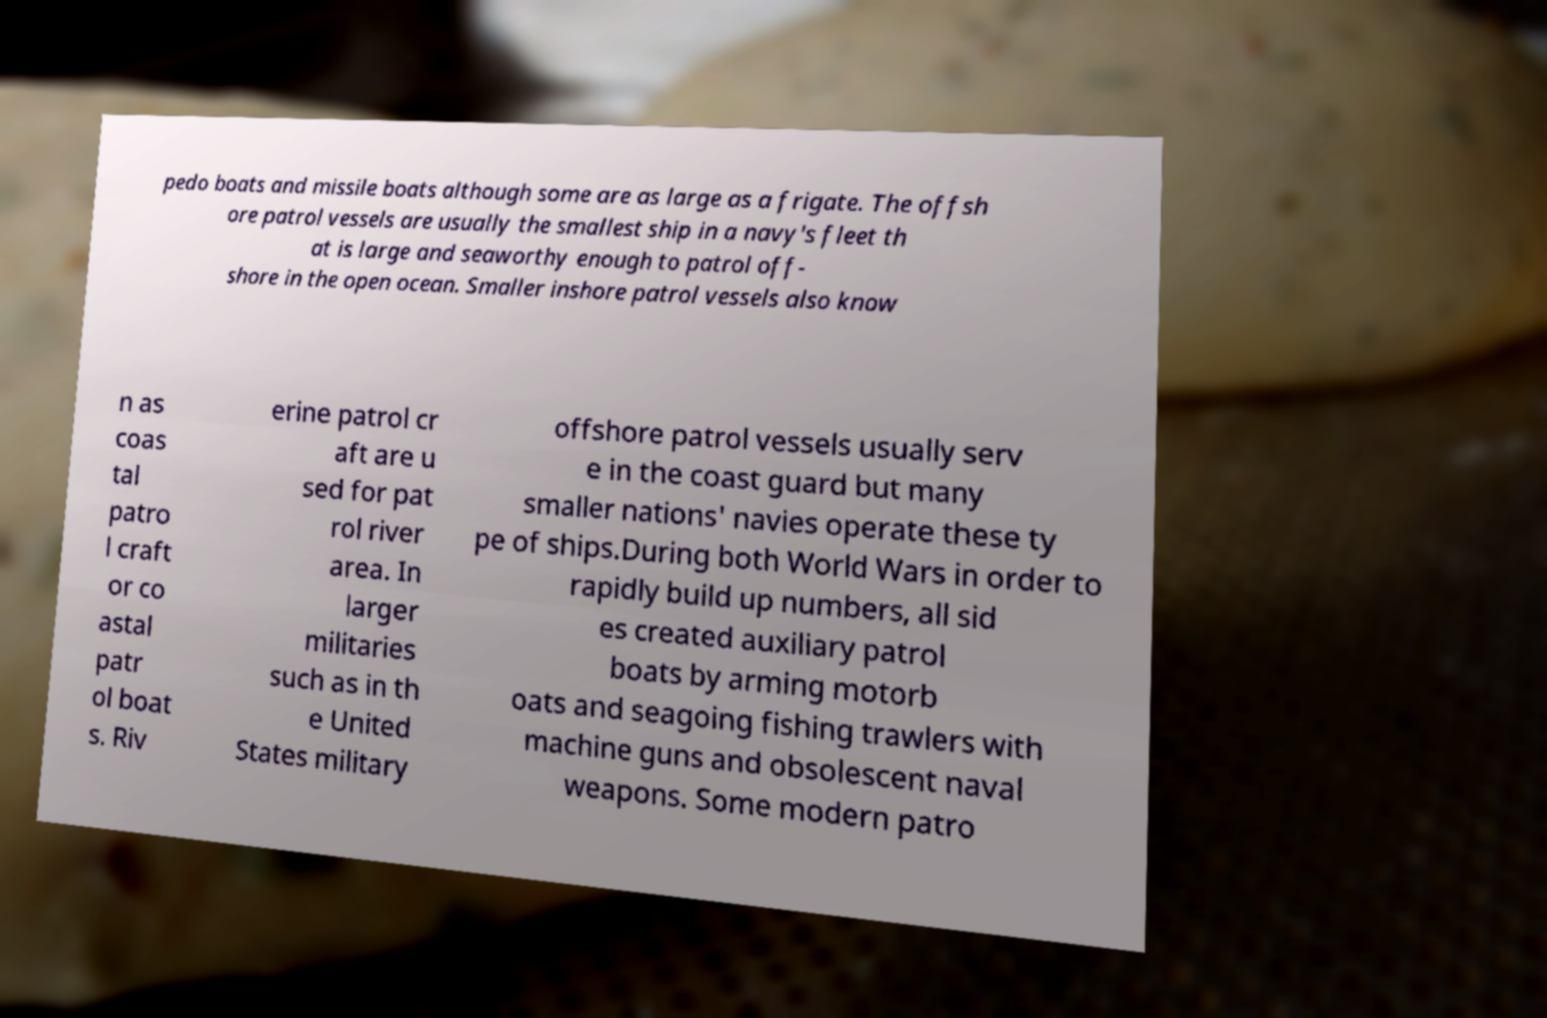Could you extract and type out the text from this image? pedo boats and missile boats although some are as large as a frigate. The offsh ore patrol vessels are usually the smallest ship in a navy's fleet th at is large and seaworthy enough to patrol off- shore in the open ocean. Smaller inshore patrol vessels also know n as coas tal patro l craft or co astal patr ol boat s. Riv erine patrol cr aft are u sed for pat rol river area. In larger militaries such as in th e United States military offshore patrol vessels usually serv e in the coast guard but many smaller nations' navies operate these ty pe of ships.During both World Wars in order to rapidly build up numbers, all sid es created auxiliary patrol boats by arming motorb oats and seagoing fishing trawlers with machine guns and obsolescent naval weapons. Some modern patro 